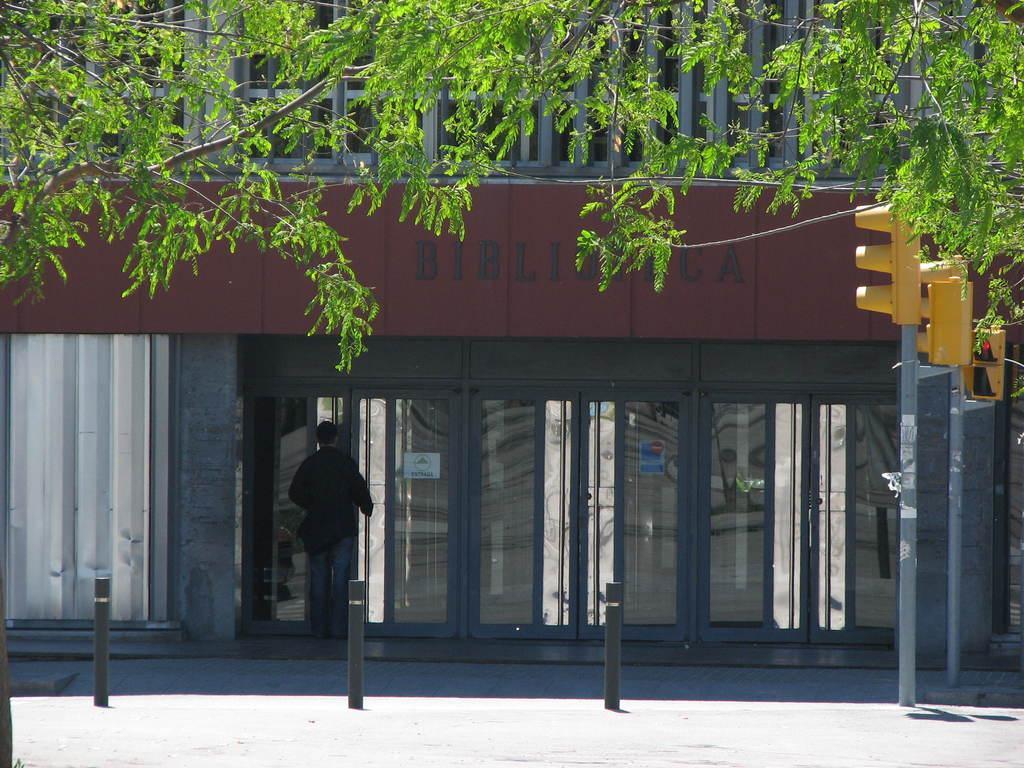Please provide a concise description of this image. In this image we can see a building, there are some trees, poles, lights, doors and a person. 